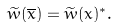Convert formula to latex. <formula><loc_0><loc_0><loc_500><loc_500>\widetilde { w } ( \overline { x } ) = \widetilde { w } ( x ) ^ { \ast } .</formula> 